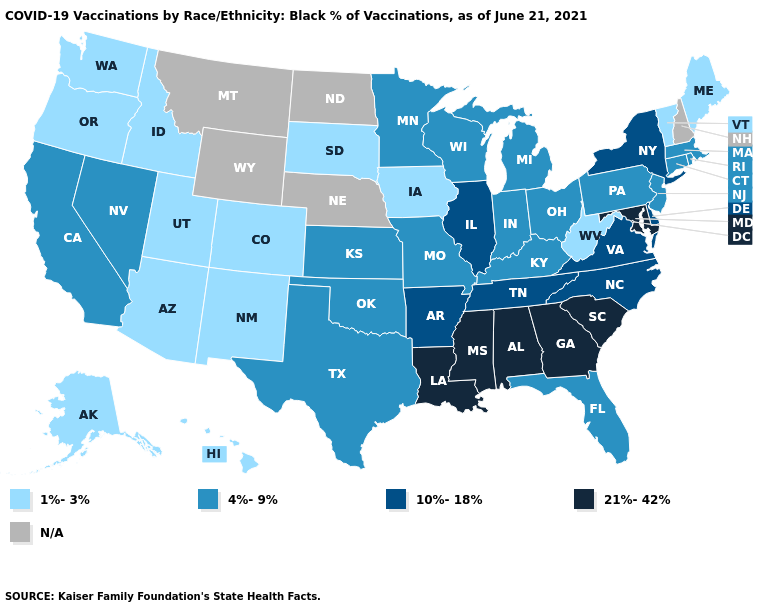Does Maryland have the highest value in the USA?
Short answer required. Yes. Among the states that border Oklahoma , which have the highest value?
Be succinct. Arkansas. Which states have the highest value in the USA?
Give a very brief answer. Alabama, Georgia, Louisiana, Maryland, Mississippi, South Carolina. What is the lowest value in states that border Utah?
Keep it brief. 1%-3%. What is the value of Missouri?
Be succinct. 4%-9%. Name the states that have a value in the range 1%-3%?
Quick response, please. Alaska, Arizona, Colorado, Hawaii, Idaho, Iowa, Maine, New Mexico, Oregon, South Dakota, Utah, Vermont, Washington, West Virginia. Name the states that have a value in the range 1%-3%?
Quick response, please. Alaska, Arizona, Colorado, Hawaii, Idaho, Iowa, Maine, New Mexico, Oregon, South Dakota, Utah, Vermont, Washington, West Virginia. What is the value of Minnesota?
Write a very short answer. 4%-9%. Name the states that have a value in the range 21%-42%?
Give a very brief answer. Alabama, Georgia, Louisiana, Maryland, Mississippi, South Carolina. What is the lowest value in states that border South Carolina?
Be succinct. 10%-18%. Name the states that have a value in the range 21%-42%?
Be succinct. Alabama, Georgia, Louisiana, Maryland, Mississippi, South Carolina. Name the states that have a value in the range 10%-18%?
Answer briefly. Arkansas, Delaware, Illinois, New York, North Carolina, Tennessee, Virginia. What is the highest value in the West ?
Concise answer only. 4%-9%. What is the lowest value in the MidWest?
Quick response, please. 1%-3%. Name the states that have a value in the range 10%-18%?
Write a very short answer. Arkansas, Delaware, Illinois, New York, North Carolina, Tennessee, Virginia. 